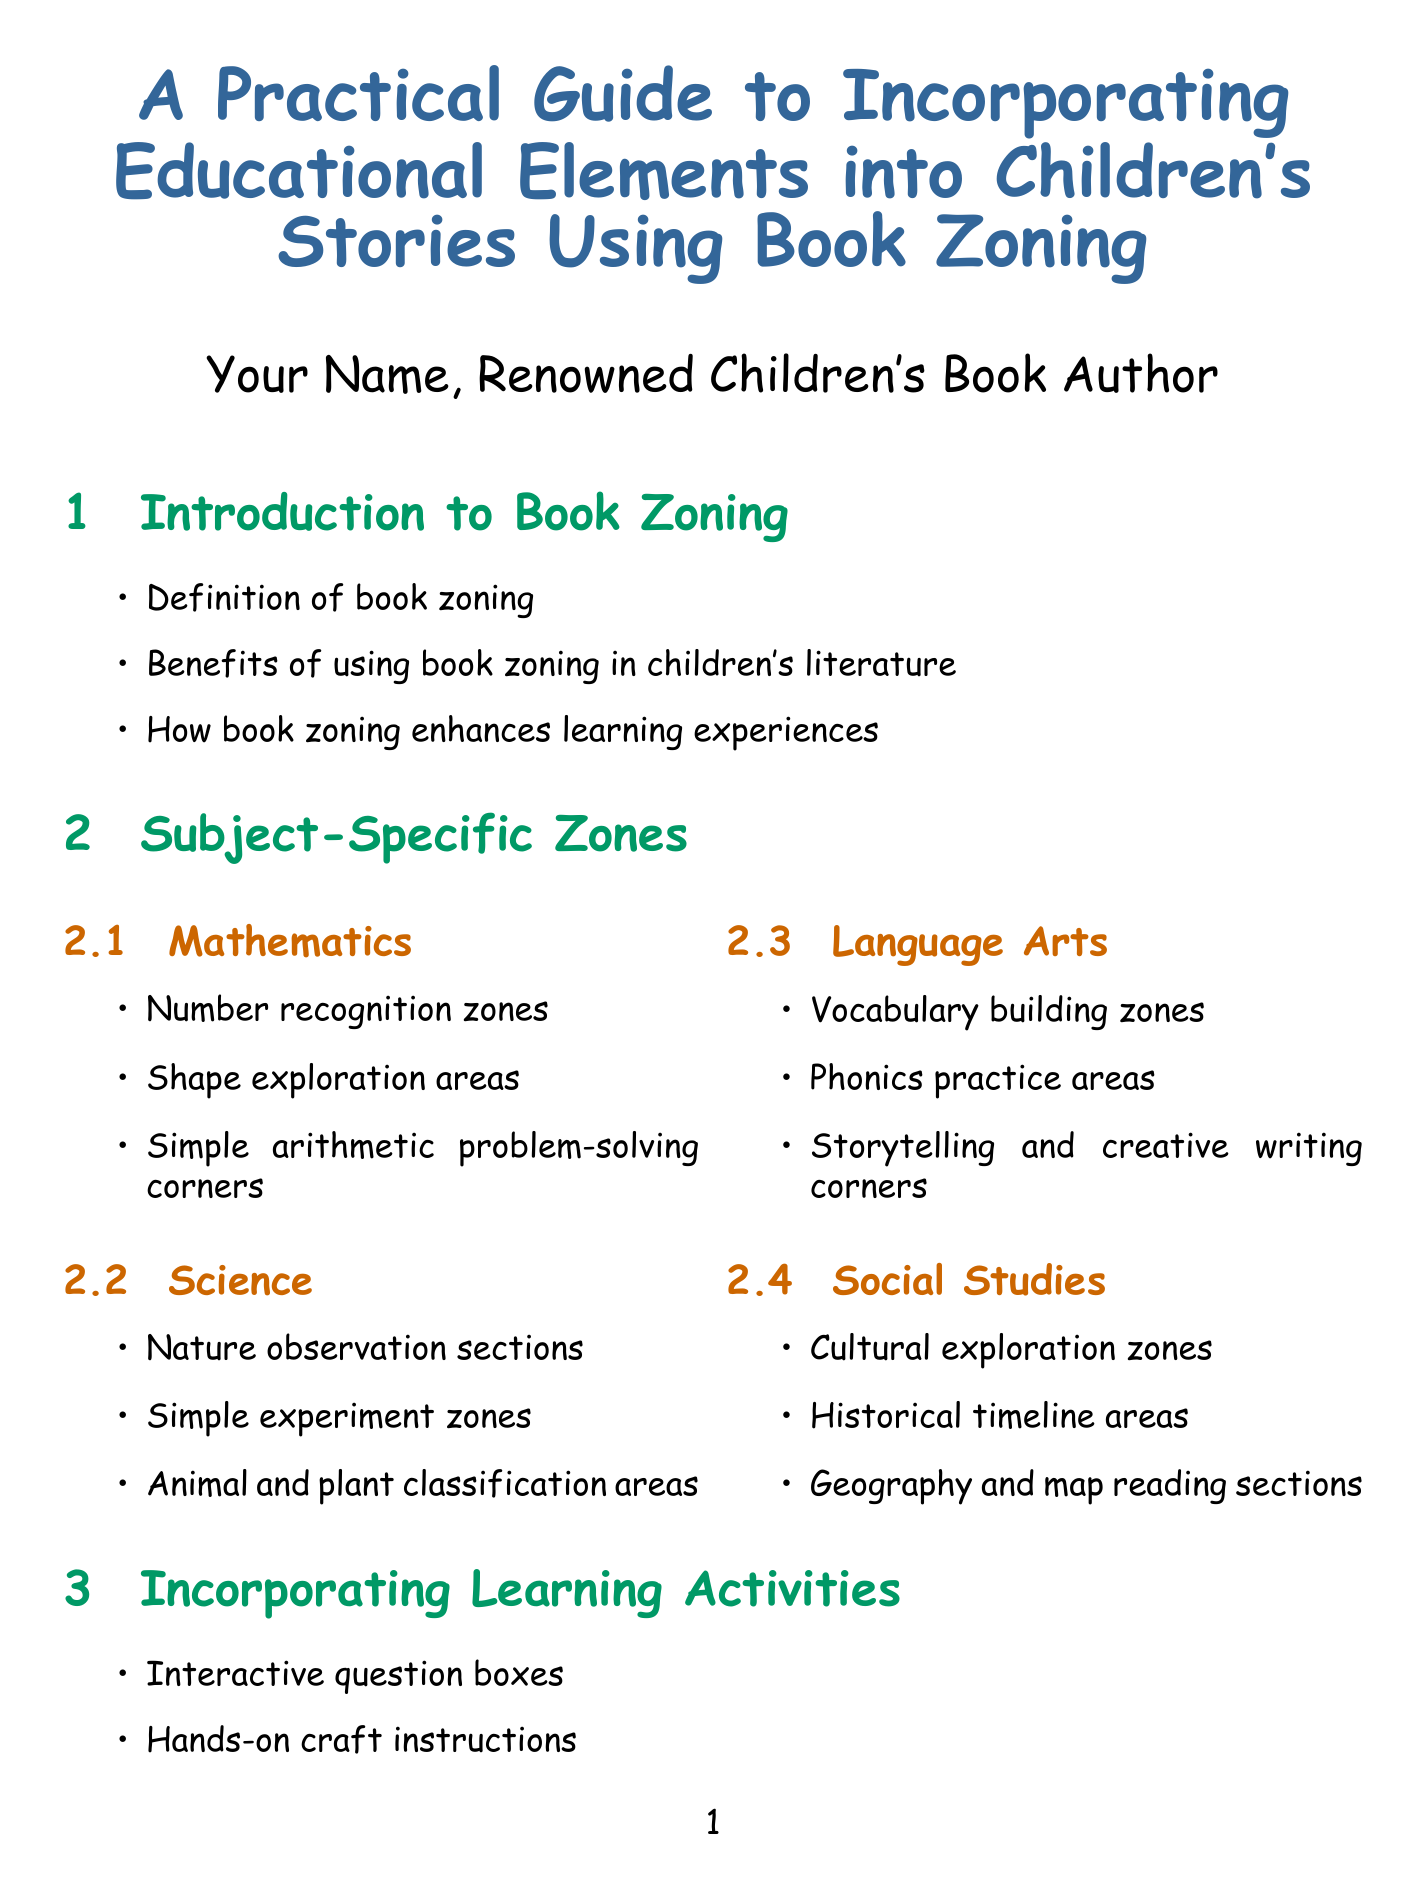What is the title of the guide? The title is a clear indication of the content focus, specifically addressing the incorporation of educational elements in children's literature.
Answer: A Practical Guide to Incorporating Educational Elements into Children's Stories Using Book Zoning Who is the author of the document? The author is prominently mentioned in the title section, highlighting their experience and recognition in children's literature.
Answer: Your Name, Renowned Children's Book Author What subject is included in the Subject-Specific Zones? The section enumerates various subjects where educational components can be integrated into children's stories.
Answer: Mathematics What is one example of a learning activity mentioned? The document lists several types of learning activities that can be incorporated, giving insight into interactive elements.
Answer: Interactive question boxes Which book by Andrea Beaty is referenced in the case studies? The case studies provide specific examples of children's books that effectively use the book zoning technique, including the author's name.
Answer: Rosie Revere, Engineer What design consideration is mentioned regarding color schemes? The document outlines key design considerations to enhance readability and engagement.
Answer: Age-appropriate color schemes How many case studies are included in the document? Counting the titles in the case studies section indicates the number of different examples provided.
Answer: Three What is one future trend in book zoning? The document hints at evolving practices and advancements in book zoning methodologies.
Answer: Integration with digital platforms 